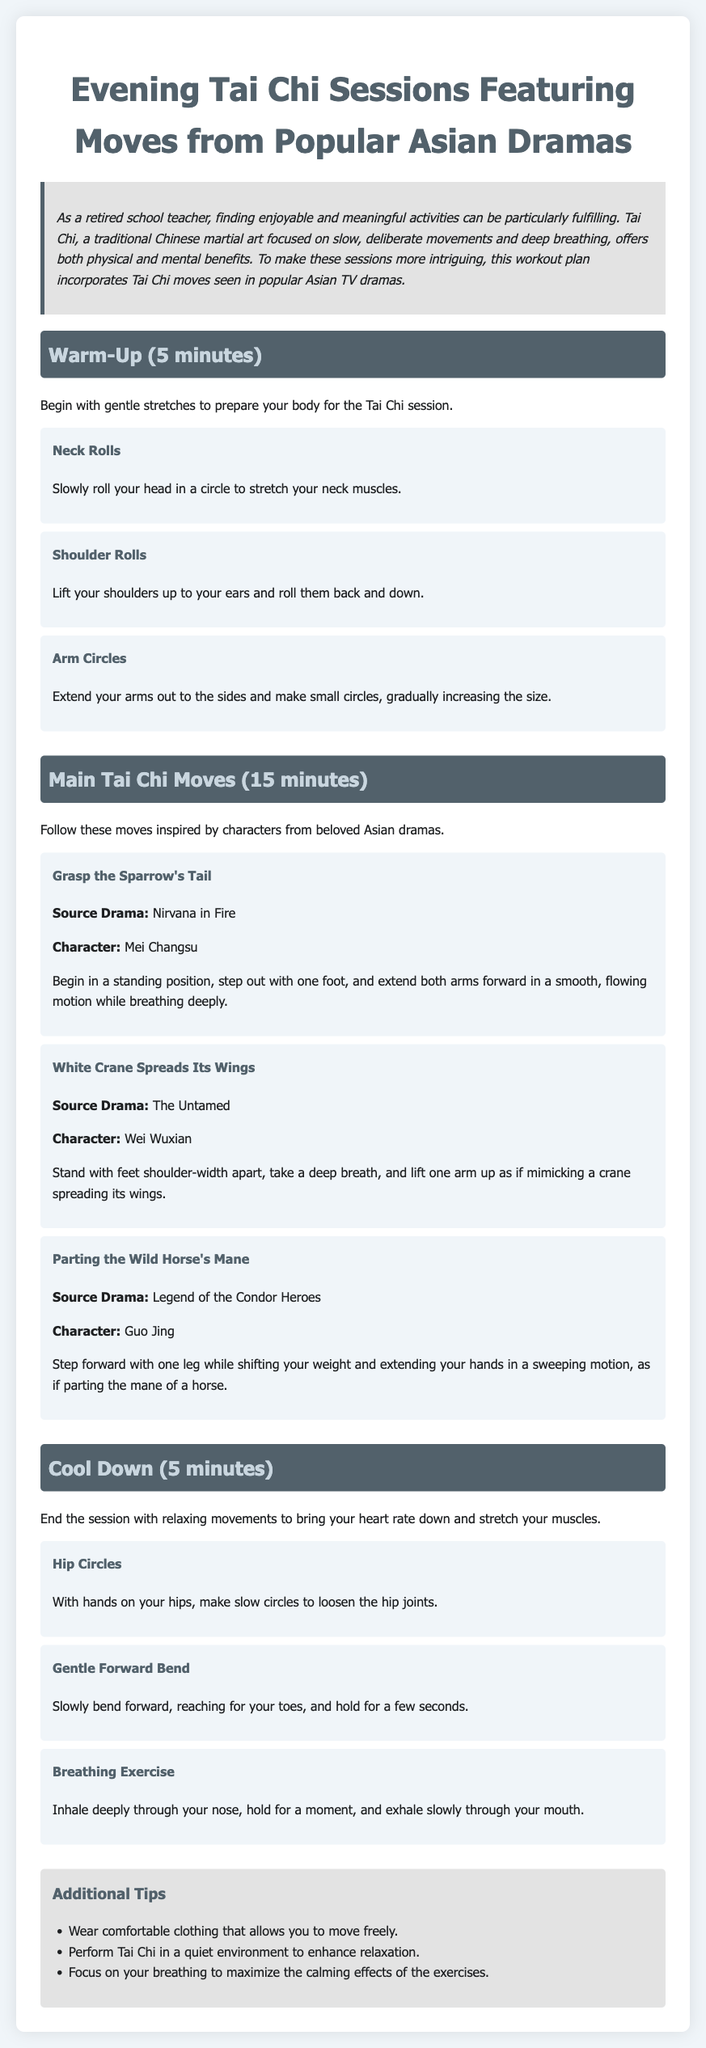What is the total duration of the Tai Chi session? The total duration includes the warm-up (5 minutes), main moves (15 minutes), and cool down (5 minutes), which adds up to 25 minutes.
Answer: 25 minutes Who is the character from "Nirvana in Fire" associated with the move "Grasp the Sparrow's Tail"? The character mentioned in the document for this move is Mei Changsu.
Answer: Mei Changsu What should you do during the cool down phase? The cool down phase consists of relaxing movements to bring your heart rate down and stretch your muscles.
Answer: Relaxing movements How many main Tai Chi moves are listed in the document? There are three main Tai Chi moves detailed in this section of the document.
Answer: Three What is the first warm-up activity mentioned? The first warm-up activity listed in the document is neck rolls.
Answer: Neck rolls Which Asian drama is associated with the move "White Crane Spreads Its Wings"? The move "White Crane Spreads Its Wings" is associated with The Untamed.
Answer: The Untamed What is the color of the background in the document? The background color of the document is a light shade, specifically #f0f5f9.
Answer: #f0f5f9 What type of clothing is recommended for performing Tai Chi? The document suggests wearing comfortable clothing that allows you to move freely.
Answer: Comfortable clothing 